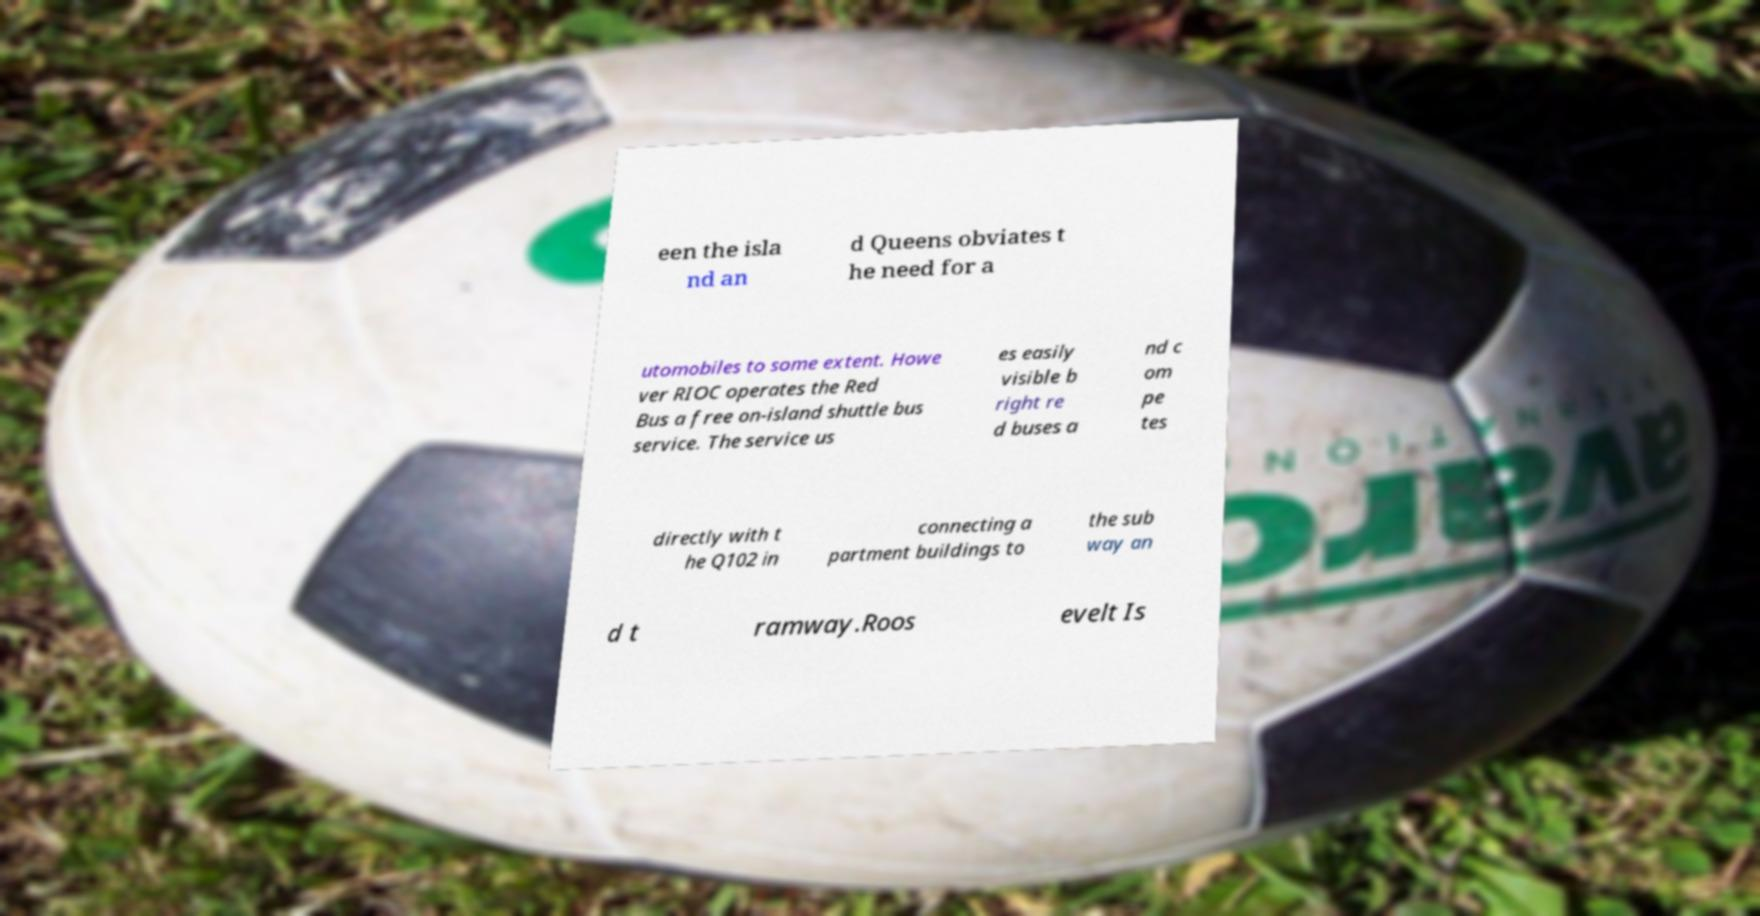There's text embedded in this image that I need extracted. Can you transcribe it verbatim? een the isla nd an d Queens obviates t he need for a utomobiles to some extent. Howe ver RIOC operates the Red Bus a free on-island shuttle bus service. The service us es easily visible b right re d buses a nd c om pe tes directly with t he Q102 in connecting a partment buildings to the sub way an d t ramway.Roos evelt Is 